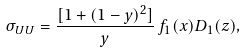<formula> <loc_0><loc_0><loc_500><loc_500>\sigma _ { U U } = \frac { [ 1 + ( 1 - y ) ^ { 2 } ] } { y } \, f _ { 1 } ( x ) D _ { 1 } ( z ) ,</formula> 